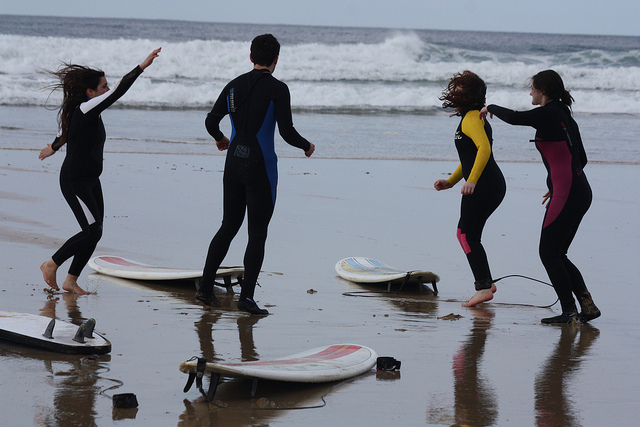How many surfboards can be seen? There are three surfboards visible in the image, each lying on the sand with individuals standing nearby, suggesting they may be taking a break or learning to surf. 